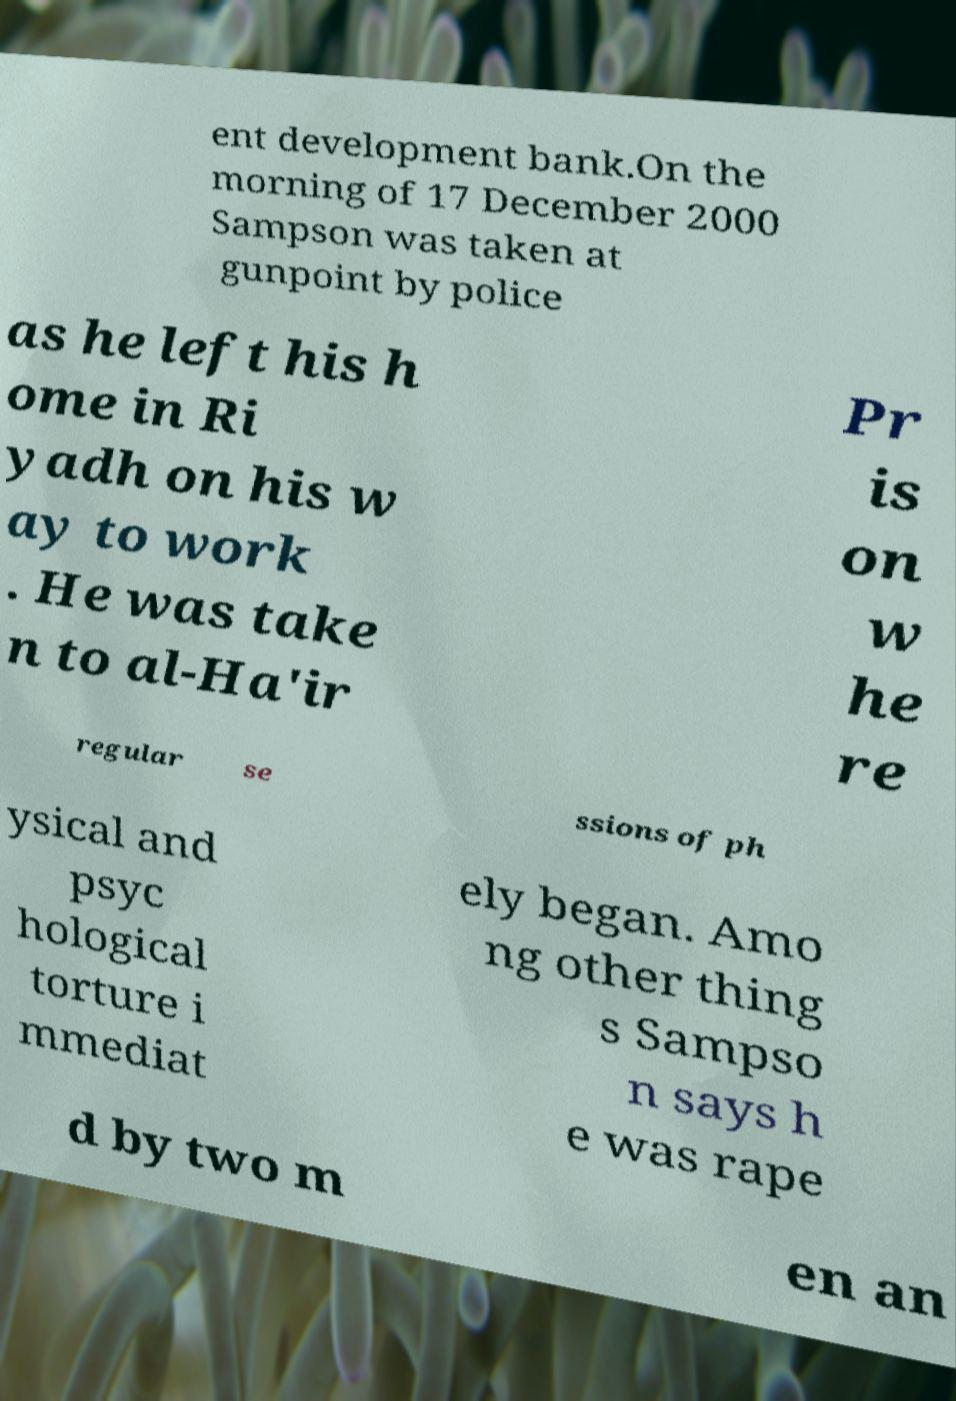Please identify and transcribe the text found in this image. ent development bank.On the morning of 17 December 2000 Sampson was taken at gunpoint by police as he left his h ome in Ri yadh on his w ay to work . He was take n to al-Ha'ir Pr is on w he re regular se ssions of ph ysical and psyc hological torture i mmediat ely began. Amo ng other thing s Sampso n says h e was rape d by two m en an 